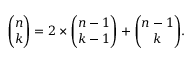Convert formula to latex. <formula><loc_0><loc_0><loc_500><loc_500>{ \binom { n } { k } } = 2 \times { \binom { n - 1 } { k - 1 } } + { \binom { n - 1 } { k } } .</formula> 